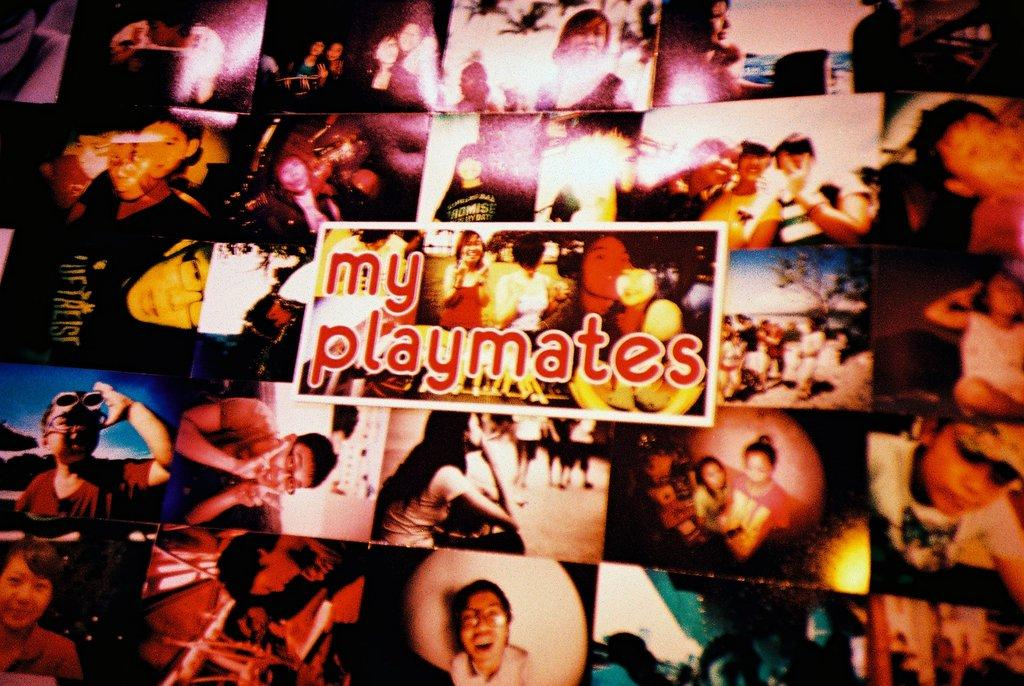What is present in the image that contains information or a message? There is a poster in the image. What can be found on the poster in the image? There is text written on the poster. How many mice are sitting on the judge's zebra in the image? There are no mice, judge, or zebra present in the image. 